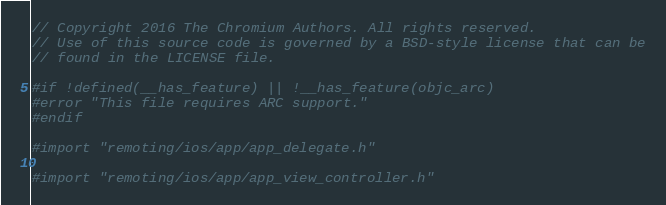<code> <loc_0><loc_0><loc_500><loc_500><_ObjectiveC_>// Copyright 2016 The Chromium Authors. All rights reserved.
// Use of this source code is governed by a BSD-style license that can be
// found in the LICENSE file.

#if !defined(__has_feature) || !__has_feature(objc_arc)
#error "This file requires ARC support."
#endif

#import "remoting/ios/app/app_delegate.h"

#import "remoting/ios/app/app_view_controller.h"</code> 